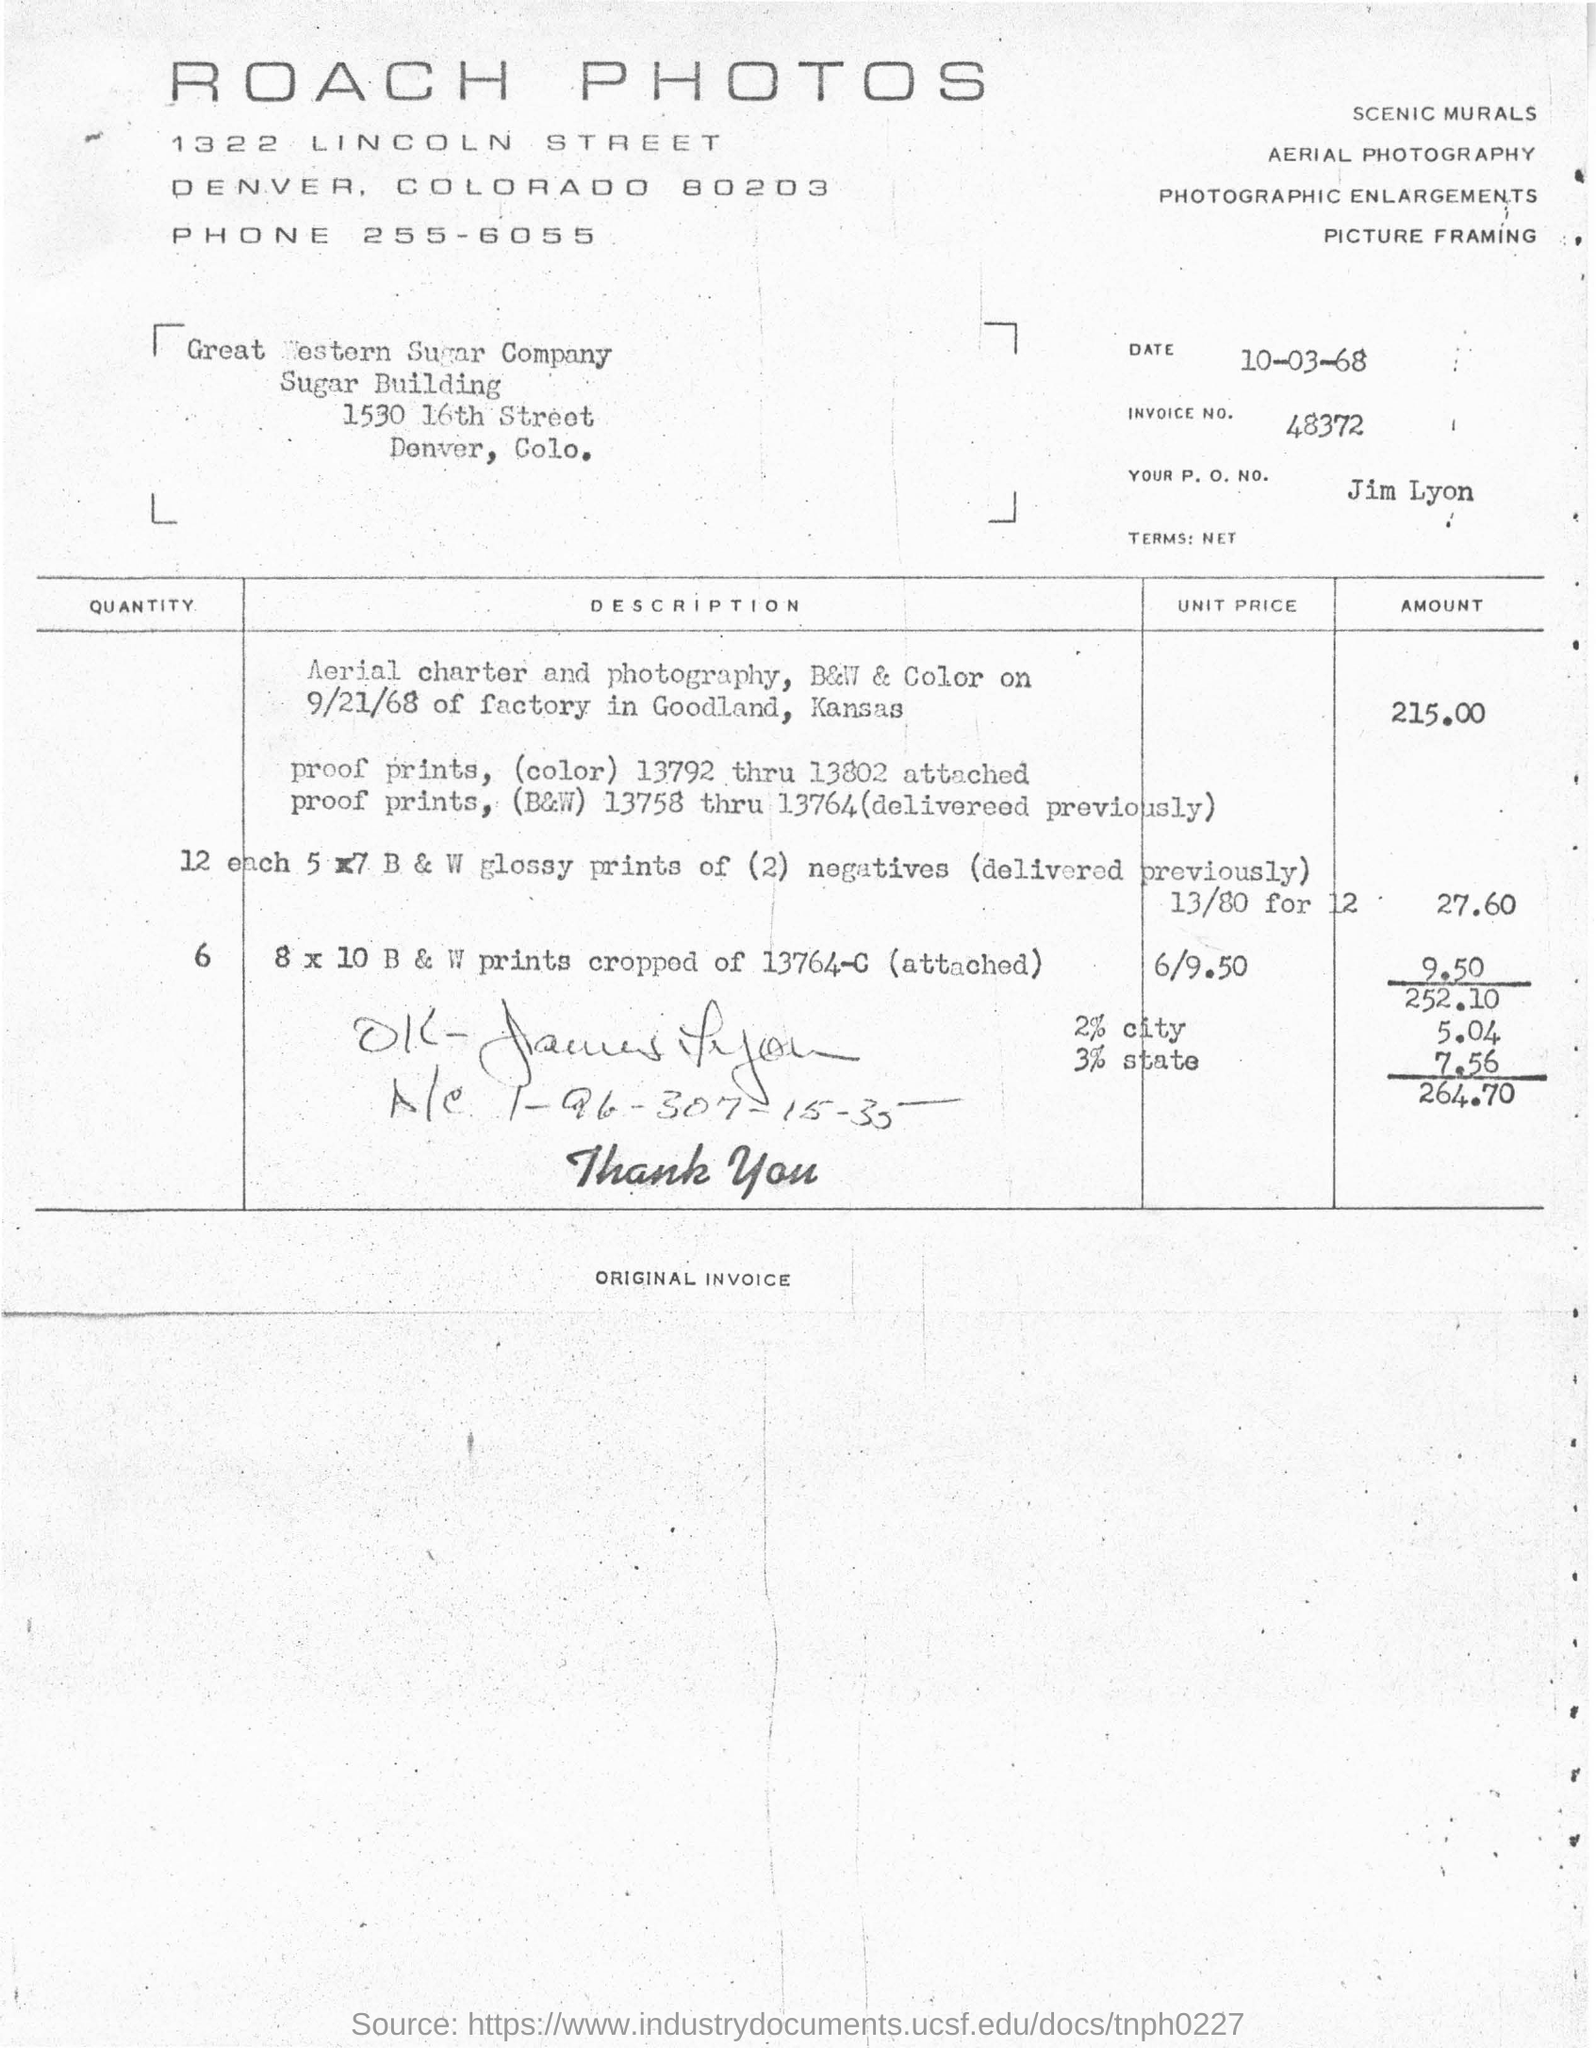List a handful of essential elements in this visual. ROACH PHOTOS is the company that is issuing the invoice. The total invoice amount mentioned in the document is 264.70. The invoice number provided in the document is 48372. The date mentioned on the invoice is March 10, 1968. The payee's name listed on the invoice is Great Western Sugar Company. 